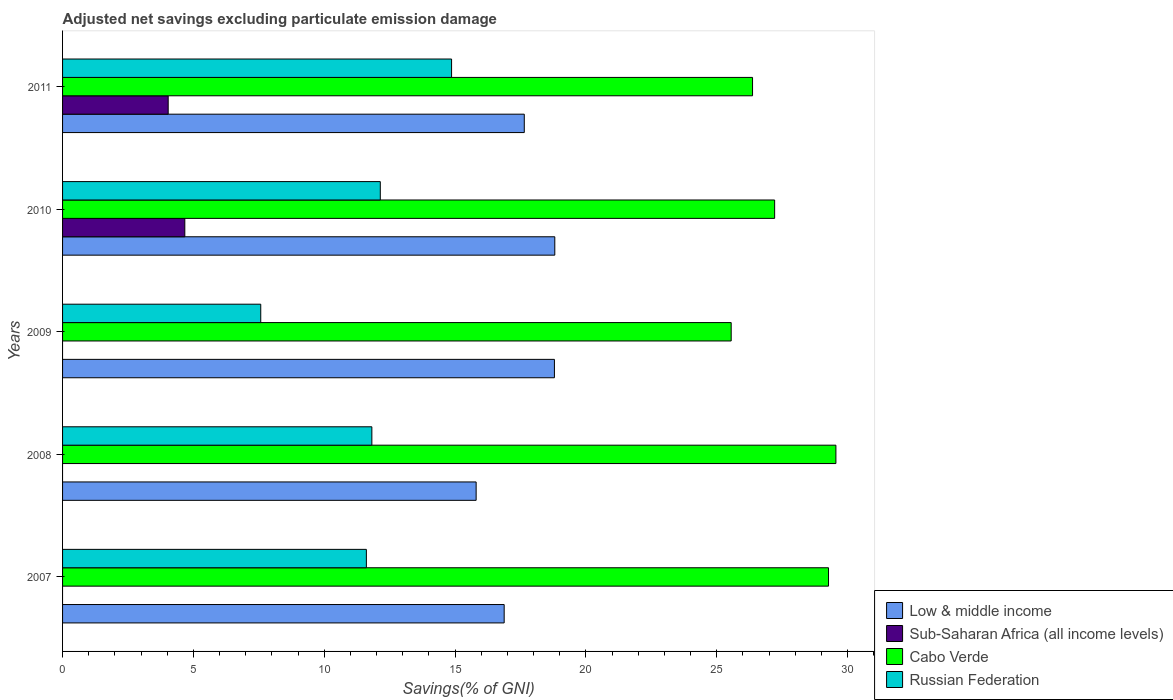How many different coloured bars are there?
Offer a terse response. 4. Are the number of bars on each tick of the Y-axis equal?
Offer a terse response. No. How many bars are there on the 5th tick from the top?
Make the answer very short. 3. What is the label of the 2nd group of bars from the top?
Make the answer very short. 2010. What is the adjusted net savings in Sub-Saharan Africa (all income levels) in 2011?
Your answer should be compact. 4.04. Across all years, what is the maximum adjusted net savings in Cabo Verde?
Ensure brevity in your answer.  29.55. Across all years, what is the minimum adjusted net savings in Low & middle income?
Your answer should be compact. 15.81. In which year was the adjusted net savings in Low & middle income maximum?
Make the answer very short. 2010. What is the total adjusted net savings in Sub-Saharan Africa (all income levels) in the graph?
Give a very brief answer. 8.71. What is the difference between the adjusted net savings in Sub-Saharan Africa (all income levels) in 2010 and that in 2011?
Your answer should be very brief. 0.64. What is the difference between the adjusted net savings in Cabo Verde in 2010 and the adjusted net savings in Sub-Saharan Africa (all income levels) in 2009?
Provide a succinct answer. 27.21. What is the average adjusted net savings in Low & middle income per year?
Offer a terse response. 17.59. In the year 2011, what is the difference between the adjusted net savings in Cabo Verde and adjusted net savings in Low & middle income?
Make the answer very short. 8.72. In how many years, is the adjusted net savings in Sub-Saharan Africa (all income levels) greater than 26 %?
Ensure brevity in your answer.  0. What is the ratio of the adjusted net savings in Cabo Verde in 2008 to that in 2011?
Offer a very short reply. 1.12. Is the adjusted net savings in Russian Federation in 2007 less than that in 2008?
Provide a short and direct response. Yes. Is the difference between the adjusted net savings in Cabo Verde in 2009 and 2011 greater than the difference between the adjusted net savings in Low & middle income in 2009 and 2011?
Give a very brief answer. No. What is the difference between the highest and the second highest adjusted net savings in Russian Federation?
Keep it short and to the point. 2.72. What is the difference between the highest and the lowest adjusted net savings in Low & middle income?
Provide a succinct answer. 3.01. In how many years, is the adjusted net savings in Low & middle income greater than the average adjusted net savings in Low & middle income taken over all years?
Your response must be concise. 3. Is the sum of the adjusted net savings in Cabo Verde in 2007 and 2010 greater than the maximum adjusted net savings in Russian Federation across all years?
Your answer should be compact. Yes. Is it the case that in every year, the sum of the adjusted net savings in Sub-Saharan Africa (all income levels) and adjusted net savings in Low & middle income is greater than the sum of adjusted net savings in Cabo Verde and adjusted net savings in Russian Federation?
Give a very brief answer. No. Is it the case that in every year, the sum of the adjusted net savings in Sub-Saharan Africa (all income levels) and adjusted net savings in Low & middle income is greater than the adjusted net savings in Russian Federation?
Make the answer very short. Yes. How many years are there in the graph?
Provide a succinct answer. 5. What is the difference between two consecutive major ticks on the X-axis?
Ensure brevity in your answer.  5. Does the graph contain any zero values?
Make the answer very short. Yes. Does the graph contain grids?
Provide a succinct answer. No. Where does the legend appear in the graph?
Your response must be concise. Bottom right. How many legend labels are there?
Give a very brief answer. 4. How are the legend labels stacked?
Keep it short and to the point. Vertical. What is the title of the graph?
Provide a succinct answer. Adjusted net savings excluding particulate emission damage. Does "Low & middle income" appear as one of the legend labels in the graph?
Provide a short and direct response. Yes. What is the label or title of the X-axis?
Give a very brief answer. Savings(% of GNI). What is the Savings(% of GNI) in Low & middle income in 2007?
Make the answer very short. 16.88. What is the Savings(% of GNI) in Sub-Saharan Africa (all income levels) in 2007?
Keep it short and to the point. 0. What is the Savings(% of GNI) of Cabo Verde in 2007?
Offer a very short reply. 29.27. What is the Savings(% of GNI) of Russian Federation in 2007?
Your response must be concise. 11.61. What is the Savings(% of GNI) in Low & middle income in 2008?
Provide a short and direct response. 15.81. What is the Savings(% of GNI) in Cabo Verde in 2008?
Keep it short and to the point. 29.55. What is the Savings(% of GNI) of Russian Federation in 2008?
Give a very brief answer. 11.82. What is the Savings(% of GNI) of Low & middle income in 2009?
Give a very brief answer. 18.8. What is the Savings(% of GNI) in Sub-Saharan Africa (all income levels) in 2009?
Make the answer very short. 0. What is the Savings(% of GNI) of Cabo Verde in 2009?
Offer a terse response. 25.55. What is the Savings(% of GNI) of Russian Federation in 2009?
Give a very brief answer. 7.57. What is the Savings(% of GNI) in Low & middle income in 2010?
Give a very brief answer. 18.81. What is the Savings(% of GNI) in Sub-Saharan Africa (all income levels) in 2010?
Keep it short and to the point. 4.67. What is the Savings(% of GNI) in Cabo Verde in 2010?
Your response must be concise. 27.21. What is the Savings(% of GNI) of Russian Federation in 2010?
Your answer should be compact. 12.14. What is the Savings(% of GNI) in Low & middle income in 2011?
Give a very brief answer. 17.65. What is the Savings(% of GNI) of Sub-Saharan Africa (all income levels) in 2011?
Offer a terse response. 4.04. What is the Savings(% of GNI) of Cabo Verde in 2011?
Give a very brief answer. 26.37. What is the Savings(% of GNI) in Russian Federation in 2011?
Offer a very short reply. 14.87. Across all years, what is the maximum Savings(% of GNI) of Low & middle income?
Give a very brief answer. 18.81. Across all years, what is the maximum Savings(% of GNI) in Sub-Saharan Africa (all income levels)?
Offer a very short reply. 4.67. Across all years, what is the maximum Savings(% of GNI) of Cabo Verde?
Your answer should be compact. 29.55. Across all years, what is the maximum Savings(% of GNI) of Russian Federation?
Give a very brief answer. 14.87. Across all years, what is the minimum Savings(% of GNI) of Low & middle income?
Keep it short and to the point. 15.81. Across all years, what is the minimum Savings(% of GNI) in Sub-Saharan Africa (all income levels)?
Your answer should be compact. 0. Across all years, what is the minimum Savings(% of GNI) in Cabo Verde?
Provide a short and direct response. 25.55. Across all years, what is the minimum Savings(% of GNI) of Russian Federation?
Ensure brevity in your answer.  7.57. What is the total Savings(% of GNI) of Low & middle income in the graph?
Ensure brevity in your answer.  87.94. What is the total Savings(% of GNI) in Sub-Saharan Africa (all income levels) in the graph?
Ensure brevity in your answer.  8.71. What is the total Savings(% of GNI) of Cabo Verde in the graph?
Ensure brevity in your answer.  137.96. What is the total Savings(% of GNI) in Russian Federation in the graph?
Make the answer very short. 58.01. What is the difference between the Savings(% of GNI) in Low & middle income in 2007 and that in 2008?
Offer a very short reply. 1.07. What is the difference between the Savings(% of GNI) in Cabo Verde in 2007 and that in 2008?
Provide a succinct answer. -0.28. What is the difference between the Savings(% of GNI) in Russian Federation in 2007 and that in 2008?
Offer a terse response. -0.21. What is the difference between the Savings(% of GNI) in Low & middle income in 2007 and that in 2009?
Your answer should be compact. -1.92. What is the difference between the Savings(% of GNI) in Cabo Verde in 2007 and that in 2009?
Your answer should be very brief. 3.72. What is the difference between the Savings(% of GNI) of Russian Federation in 2007 and that in 2009?
Your answer should be very brief. 4.04. What is the difference between the Savings(% of GNI) in Low & middle income in 2007 and that in 2010?
Offer a terse response. -1.93. What is the difference between the Savings(% of GNI) in Cabo Verde in 2007 and that in 2010?
Your answer should be compact. 2.06. What is the difference between the Savings(% of GNI) in Russian Federation in 2007 and that in 2010?
Your response must be concise. -0.53. What is the difference between the Savings(% of GNI) in Low & middle income in 2007 and that in 2011?
Ensure brevity in your answer.  -0.77. What is the difference between the Savings(% of GNI) of Cabo Verde in 2007 and that in 2011?
Give a very brief answer. 2.9. What is the difference between the Savings(% of GNI) of Russian Federation in 2007 and that in 2011?
Your answer should be compact. -3.26. What is the difference between the Savings(% of GNI) in Low & middle income in 2008 and that in 2009?
Ensure brevity in your answer.  -2.99. What is the difference between the Savings(% of GNI) of Cabo Verde in 2008 and that in 2009?
Your response must be concise. 4. What is the difference between the Savings(% of GNI) in Russian Federation in 2008 and that in 2009?
Ensure brevity in your answer.  4.25. What is the difference between the Savings(% of GNI) in Low & middle income in 2008 and that in 2010?
Offer a terse response. -3.01. What is the difference between the Savings(% of GNI) in Cabo Verde in 2008 and that in 2010?
Ensure brevity in your answer.  2.34. What is the difference between the Savings(% of GNI) in Russian Federation in 2008 and that in 2010?
Give a very brief answer. -0.32. What is the difference between the Savings(% of GNI) of Low & middle income in 2008 and that in 2011?
Offer a terse response. -1.84. What is the difference between the Savings(% of GNI) in Cabo Verde in 2008 and that in 2011?
Keep it short and to the point. 3.19. What is the difference between the Savings(% of GNI) in Russian Federation in 2008 and that in 2011?
Provide a succinct answer. -3.05. What is the difference between the Savings(% of GNI) in Low & middle income in 2009 and that in 2010?
Your answer should be compact. -0.01. What is the difference between the Savings(% of GNI) in Cabo Verde in 2009 and that in 2010?
Your answer should be compact. -1.66. What is the difference between the Savings(% of GNI) in Russian Federation in 2009 and that in 2010?
Your answer should be compact. -4.57. What is the difference between the Savings(% of GNI) in Low & middle income in 2009 and that in 2011?
Your response must be concise. 1.15. What is the difference between the Savings(% of GNI) in Cabo Verde in 2009 and that in 2011?
Your answer should be compact. -0.82. What is the difference between the Savings(% of GNI) in Russian Federation in 2009 and that in 2011?
Ensure brevity in your answer.  -7.29. What is the difference between the Savings(% of GNI) of Low & middle income in 2010 and that in 2011?
Give a very brief answer. 1.17. What is the difference between the Savings(% of GNI) in Sub-Saharan Africa (all income levels) in 2010 and that in 2011?
Your answer should be compact. 0.64. What is the difference between the Savings(% of GNI) in Cabo Verde in 2010 and that in 2011?
Give a very brief answer. 0.84. What is the difference between the Savings(% of GNI) in Russian Federation in 2010 and that in 2011?
Your response must be concise. -2.72. What is the difference between the Savings(% of GNI) in Low & middle income in 2007 and the Savings(% of GNI) in Cabo Verde in 2008?
Your answer should be compact. -12.68. What is the difference between the Savings(% of GNI) of Low & middle income in 2007 and the Savings(% of GNI) of Russian Federation in 2008?
Provide a succinct answer. 5.06. What is the difference between the Savings(% of GNI) in Cabo Verde in 2007 and the Savings(% of GNI) in Russian Federation in 2008?
Ensure brevity in your answer.  17.45. What is the difference between the Savings(% of GNI) in Low & middle income in 2007 and the Savings(% of GNI) in Cabo Verde in 2009?
Give a very brief answer. -8.68. What is the difference between the Savings(% of GNI) in Low & middle income in 2007 and the Savings(% of GNI) in Russian Federation in 2009?
Provide a short and direct response. 9.3. What is the difference between the Savings(% of GNI) of Cabo Verde in 2007 and the Savings(% of GNI) of Russian Federation in 2009?
Give a very brief answer. 21.7. What is the difference between the Savings(% of GNI) of Low & middle income in 2007 and the Savings(% of GNI) of Sub-Saharan Africa (all income levels) in 2010?
Ensure brevity in your answer.  12.2. What is the difference between the Savings(% of GNI) in Low & middle income in 2007 and the Savings(% of GNI) in Cabo Verde in 2010?
Offer a terse response. -10.34. What is the difference between the Savings(% of GNI) in Low & middle income in 2007 and the Savings(% of GNI) in Russian Federation in 2010?
Make the answer very short. 4.73. What is the difference between the Savings(% of GNI) of Cabo Verde in 2007 and the Savings(% of GNI) of Russian Federation in 2010?
Your answer should be very brief. 17.13. What is the difference between the Savings(% of GNI) in Low & middle income in 2007 and the Savings(% of GNI) in Sub-Saharan Africa (all income levels) in 2011?
Your answer should be very brief. 12.84. What is the difference between the Savings(% of GNI) of Low & middle income in 2007 and the Savings(% of GNI) of Cabo Verde in 2011?
Offer a very short reply. -9.49. What is the difference between the Savings(% of GNI) of Low & middle income in 2007 and the Savings(% of GNI) of Russian Federation in 2011?
Give a very brief answer. 2.01. What is the difference between the Savings(% of GNI) of Cabo Verde in 2007 and the Savings(% of GNI) of Russian Federation in 2011?
Provide a succinct answer. 14.41. What is the difference between the Savings(% of GNI) of Low & middle income in 2008 and the Savings(% of GNI) of Cabo Verde in 2009?
Make the answer very short. -9.75. What is the difference between the Savings(% of GNI) in Low & middle income in 2008 and the Savings(% of GNI) in Russian Federation in 2009?
Provide a short and direct response. 8.23. What is the difference between the Savings(% of GNI) of Cabo Verde in 2008 and the Savings(% of GNI) of Russian Federation in 2009?
Offer a terse response. 21.98. What is the difference between the Savings(% of GNI) of Low & middle income in 2008 and the Savings(% of GNI) of Sub-Saharan Africa (all income levels) in 2010?
Give a very brief answer. 11.13. What is the difference between the Savings(% of GNI) of Low & middle income in 2008 and the Savings(% of GNI) of Cabo Verde in 2010?
Give a very brief answer. -11.41. What is the difference between the Savings(% of GNI) of Low & middle income in 2008 and the Savings(% of GNI) of Russian Federation in 2010?
Offer a very short reply. 3.66. What is the difference between the Savings(% of GNI) of Cabo Verde in 2008 and the Savings(% of GNI) of Russian Federation in 2010?
Give a very brief answer. 17.41. What is the difference between the Savings(% of GNI) of Low & middle income in 2008 and the Savings(% of GNI) of Sub-Saharan Africa (all income levels) in 2011?
Make the answer very short. 11.77. What is the difference between the Savings(% of GNI) of Low & middle income in 2008 and the Savings(% of GNI) of Cabo Verde in 2011?
Keep it short and to the point. -10.56. What is the difference between the Savings(% of GNI) in Low & middle income in 2008 and the Savings(% of GNI) in Russian Federation in 2011?
Your response must be concise. 0.94. What is the difference between the Savings(% of GNI) of Cabo Verde in 2008 and the Savings(% of GNI) of Russian Federation in 2011?
Keep it short and to the point. 14.69. What is the difference between the Savings(% of GNI) in Low & middle income in 2009 and the Savings(% of GNI) in Sub-Saharan Africa (all income levels) in 2010?
Offer a terse response. 14.13. What is the difference between the Savings(% of GNI) of Low & middle income in 2009 and the Savings(% of GNI) of Cabo Verde in 2010?
Your answer should be compact. -8.42. What is the difference between the Savings(% of GNI) of Low & middle income in 2009 and the Savings(% of GNI) of Russian Federation in 2010?
Provide a short and direct response. 6.65. What is the difference between the Savings(% of GNI) in Cabo Verde in 2009 and the Savings(% of GNI) in Russian Federation in 2010?
Give a very brief answer. 13.41. What is the difference between the Savings(% of GNI) of Low & middle income in 2009 and the Savings(% of GNI) of Sub-Saharan Africa (all income levels) in 2011?
Offer a very short reply. 14.76. What is the difference between the Savings(% of GNI) of Low & middle income in 2009 and the Savings(% of GNI) of Cabo Verde in 2011?
Ensure brevity in your answer.  -7.57. What is the difference between the Savings(% of GNI) in Low & middle income in 2009 and the Savings(% of GNI) in Russian Federation in 2011?
Your answer should be very brief. 3.93. What is the difference between the Savings(% of GNI) in Cabo Verde in 2009 and the Savings(% of GNI) in Russian Federation in 2011?
Offer a terse response. 10.69. What is the difference between the Savings(% of GNI) in Low & middle income in 2010 and the Savings(% of GNI) in Sub-Saharan Africa (all income levels) in 2011?
Make the answer very short. 14.78. What is the difference between the Savings(% of GNI) of Low & middle income in 2010 and the Savings(% of GNI) of Cabo Verde in 2011?
Provide a short and direct response. -7.56. What is the difference between the Savings(% of GNI) of Low & middle income in 2010 and the Savings(% of GNI) of Russian Federation in 2011?
Ensure brevity in your answer.  3.95. What is the difference between the Savings(% of GNI) in Sub-Saharan Africa (all income levels) in 2010 and the Savings(% of GNI) in Cabo Verde in 2011?
Provide a short and direct response. -21.7. What is the difference between the Savings(% of GNI) of Sub-Saharan Africa (all income levels) in 2010 and the Savings(% of GNI) of Russian Federation in 2011?
Your response must be concise. -10.19. What is the difference between the Savings(% of GNI) of Cabo Verde in 2010 and the Savings(% of GNI) of Russian Federation in 2011?
Provide a succinct answer. 12.35. What is the average Savings(% of GNI) of Low & middle income per year?
Give a very brief answer. 17.59. What is the average Savings(% of GNI) of Sub-Saharan Africa (all income levels) per year?
Keep it short and to the point. 1.74. What is the average Savings(% of GNI) in Cabo Verde per year?
Your answer should be compact. 27.59. What is the average Savings(% of GNI) in Russian Federation per year?
Make the answer very short. 11.6. In the year 2007, what is the difference between the Savings(% of GNI) in Low & middle income and Savings(% of GNI) in Cabo Verde?
Your answer should be compact. -12.39. In the year 2007, what is the difference between the Savings(% of GNI) in Low & middle income and Savings(% of GNI) in Russian Federation?
Keep it short and to the point. 5.27. In the year 2007, what is the difference between the Savings(% of GNI) in Cabo Verde and Savings(% of GNI) in Russian Federation?
Offer a very short reply. 17.66. In the year 2008, what is the difference between the Savings(% of GNI) in Low & middle income and Savings(% of GNI) in Cabo Verde?
Your answer should be compact. -13.75. In the year 2008, what is the difference between the Savings(% of GNI) in Low & middle income and Savings(% of GNI) in Russian Federation?
Offer a terse response. 3.99. In the year 2008, what is the difference between the Savings(% of GNI) in Cabo Verde and Savings(% of GNI) in Russian Federation?
Ensure brevity in your answer.  17.73. In the year 2009, what is the difference between the Savings(% of GNI) in Low & middle income and Savings(% of GNI) in Cabo Verde?
Offer a very short reply. -6.76. In the year 2009, what is the difference between the Savings(% of GNI) of Low & middle income and Savings(% of GNI) of Russian Federation?
Ensure brevity in your answer.  11.22. In the year 2009, what is the difference between the Savings(% of GNI) of Cabo Verde and Savings(% of GNI) of Russian Federation?
Offer a terse response. 17.98. In the year 2010, what is the difference between the Savings(% of GNI) of Low & middle income and Savings(% of GNI) of Sub-Saharan Africa (all income levels)?
Provide a succinct answer. 14.14. In the year 2010, what is the difference between the Savings(% of GNI) in Low & middle income and Savings(% of GNI) in Cabo Verde?
Keep it short and to the point. -8.4. In the year 2010, what is the difference between the Savings(% of GNI) in Low & middle income and Savings(% of GNI) in Russian Federation?
Your answer should be compact. 6.67. In the year 2010, what is the difference between the Savings(% of GNI) of Sub-Saharan Africa (all income levels) and Savings(% of GNI) of Cabo Verde?
Provide a short and direct response. -22.54. In the year 2010, what is the difference between the Savings(% of GNI) of Sub-Saharan Africa (all income levels) and Savings(% of GNI) of Russian Federation?
Ensure brevity in your answer.  -7.47. In the year 2010, what is the difference between the Savings(% of GNI) in Cabo Verde and Savings(% of GNI) in Russian Federation?
Provide a short and direct response. 15.07. In the year 2011, what is the difference between the Savings(% of GNI) of Low & middle income and Savings(% of GNI) of Sub-Saharan Africa (all income levels)?
Give a very brief answer. 13.61. In the year 2011, what is the difference between the Savings(% of GNI) of Low & middle income and Savings(% of GNI) of Cabo Verde?
Provide a succinct answer. -8.72. In the year 2011, what is the difference between the Savings(% of GNI) of Low & middle income and Savings(% of GNI) of Russian Federation?
Offer a very short reply. 2.78. In the year 2011, what is the difference between the Savings(% of GNI) in Sub-Saharan Africa (all income levels) and Savings(% of GNI) in Cabo Verde?
Your answer should be compact. -22.33. In the year 2011, what is the difference between the Savings(% of GNI) in Sub-Saharan Africa (all income levels) and Savings(% of GNI) in Russian Federation?
Give a very brief answer. -10.83. In the year 2011, what is the difference between the Savings(% of GNI) in Cabo Verde and Savings(% of GNI) in Russian Federation?
Give a very brief answer. 11.5. What is the ratio of the Savings(% of GNI) in Low & middle income in 2007 to that in 2008?
Ensure brevity in your answer.  1.07. What is the ratio of the Savings(% of GNI) in Russian Federation in 2007 to that in 2008?
Offer a terse response. 0.98. What is the ratio of the Savings(% of GNI) of Low & middle income in 2007 to that in 2009?
Your response must be concise. 0.9. What is the ratio of the Savings(% of GNI) of Cabo Verde in 2007 to that in 2009?
Offer a terse response. 1.15. What is the ratio of the Savings(% of GNI) in Russian Federation in 2007 to that in 2009?
Your answer should be very brief. 1.53. What is the ratio of the Savings(% of GNI) of Low & middle income in 2007 to that in 2010?
Your answer should be very brief. 0.9. What is the ratio of the Savings(% of GNI) in Cabo Verde in 2007 to that in 2010?
Your answer should be very brief. 1.08. What is the ratio of the Savings(% of GNI) of Russian Federation in 2007 to that in 2010?
Keep it short and to the point. 0.96. What is the ratio of the Savings(% of GNI) in Low & middle income in 2007 to that in 2011?
Provide a succinct answer. 0.96. What is the ratio of the Savings(% of GNI) in Cabo Verde in 2007 to that in 2011?
Ensure brevity in your answer.  1.11. What is the ratio of the Savings(% of GNI) of Russian Federation in 2007 to that in 2011?
Your response must be concise. 0.78. What is the ratio of the Savings(% of GNI) of Low & middle income in 2008 to that in 2009?
Your answer should be compact. 0.84. What is the ratio of the Savings(% of GNI) in Cabo Verde in 2008 to that in 2009?
Provide a short and direct response. 1.16. What is the ratio of the Savings(% of GNI) of Russian Federation in 2008 to that in 2009?
Provide a short and direct response. 1.56. What is the ratio of the Savings(% of GNI) in Low & middle income in 2008 to that in 2010?
Ensure brevity in your answer.  0.84. What is the ratio of the Savings(% of GNI) of Cabo Verde in 2008 to that in 2010?
Your answer should be compact. 1.09. What is the ratio of the Savings(% of GNI) in Russian Federation in 2008 to that in 2010?
Your answer should be compact. 0.97. What is the ratio of the Savings(% of GNI) of Low & middle income in 2008 to that in 2011?
Give a very brief answer. 0.9. What is the ratio of the Savings(% of GNI) of Cabo Verde in 2008 to that in 2011?
Offer a terse response. 1.12. What is the ratio of the Savings(% of GNI) of Russian Federation in 2008 to that in 2011?
Provide a short and direct response. 0.8. What is the ratio of the Savings(% of GNI) in Low & middle income in 2009 to that in 2010?
Provide a succinct answer. 1. What is the ratio of the Savings(% of GNI) of Cabo Verde in 2009 to that in 2010?
Your answer should be compact. 0.94. What is the ratio of the Savings(% of GNI) of Russian Federation in 2009 to that in 2010?
Provide a succinct answer. 0.62. What is the ratio of the Savings(% of GNI) in Low & middle income in 2009 to that in 2011?
Your response must be concise. 1.07. What is the ratio of the Savings(% of GNI) in Russian Federation in 2009 to that in 2011?
Provide a succinct answer. 0.51. What is the ratio of the Savings(% of GNI) of Low & middle income in 2010 to that in 2011?
Your response must be concise. 1.07. What is the ratio of the Savings(% of GNI) in Sub-Saharan Africa (all income levels) in 2010 to that in 2011?
Offer a very short reply. 1.16. What is the ratio of the Savings(% of GNI) of Cabo Verde in 2010 to that in 2011?
Give a very brief answer. 1.03. What is the ratio of the Savings(% of GNI) in Russian Federation in 2010 to that in 2011?
Provide a short and direct response. 0.82. What is the difference between the highest and the second highest Savings(% of GNI) in Low & middle income?
Your response must be concise. 0.01. What is the difference between the highest and the second highest Savings(% of GNI) in Cabo Verde?
Keep it short and to the point. 0.28. What is the difference between the highest and the second highest Savings(% of GNI) in Russian Federation?
Make the answer very short. 2.72. What is the difference between the highest and the lowest Savings(% of GNI) of Low & middle income?
Provide a short and direct response. 3.01. What is the difference between the highest and the lowest Savings(% of GNI) of Sub-Saharan Africa (all income levels)?
Offer a very short reply. 4.67. What is the difference between the highest and the lowest Savings(% of GNI) in Cabo Verde?
Offer a terse response. 4. What is the difference between the highest and the lowest Savings(% of GNI) in Russian Federation?
Offer a terse response. 7.29. 